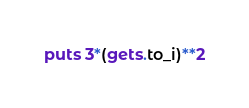<code> <loc_0><loc_0><loc_500><loc_500><_Ruby_>puts 3*(gets.to_i)**2
</code> 